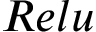Convert formula to latex. <formula><loc_0><loc_0><loc_500><loc_500>R e l u</formula> 